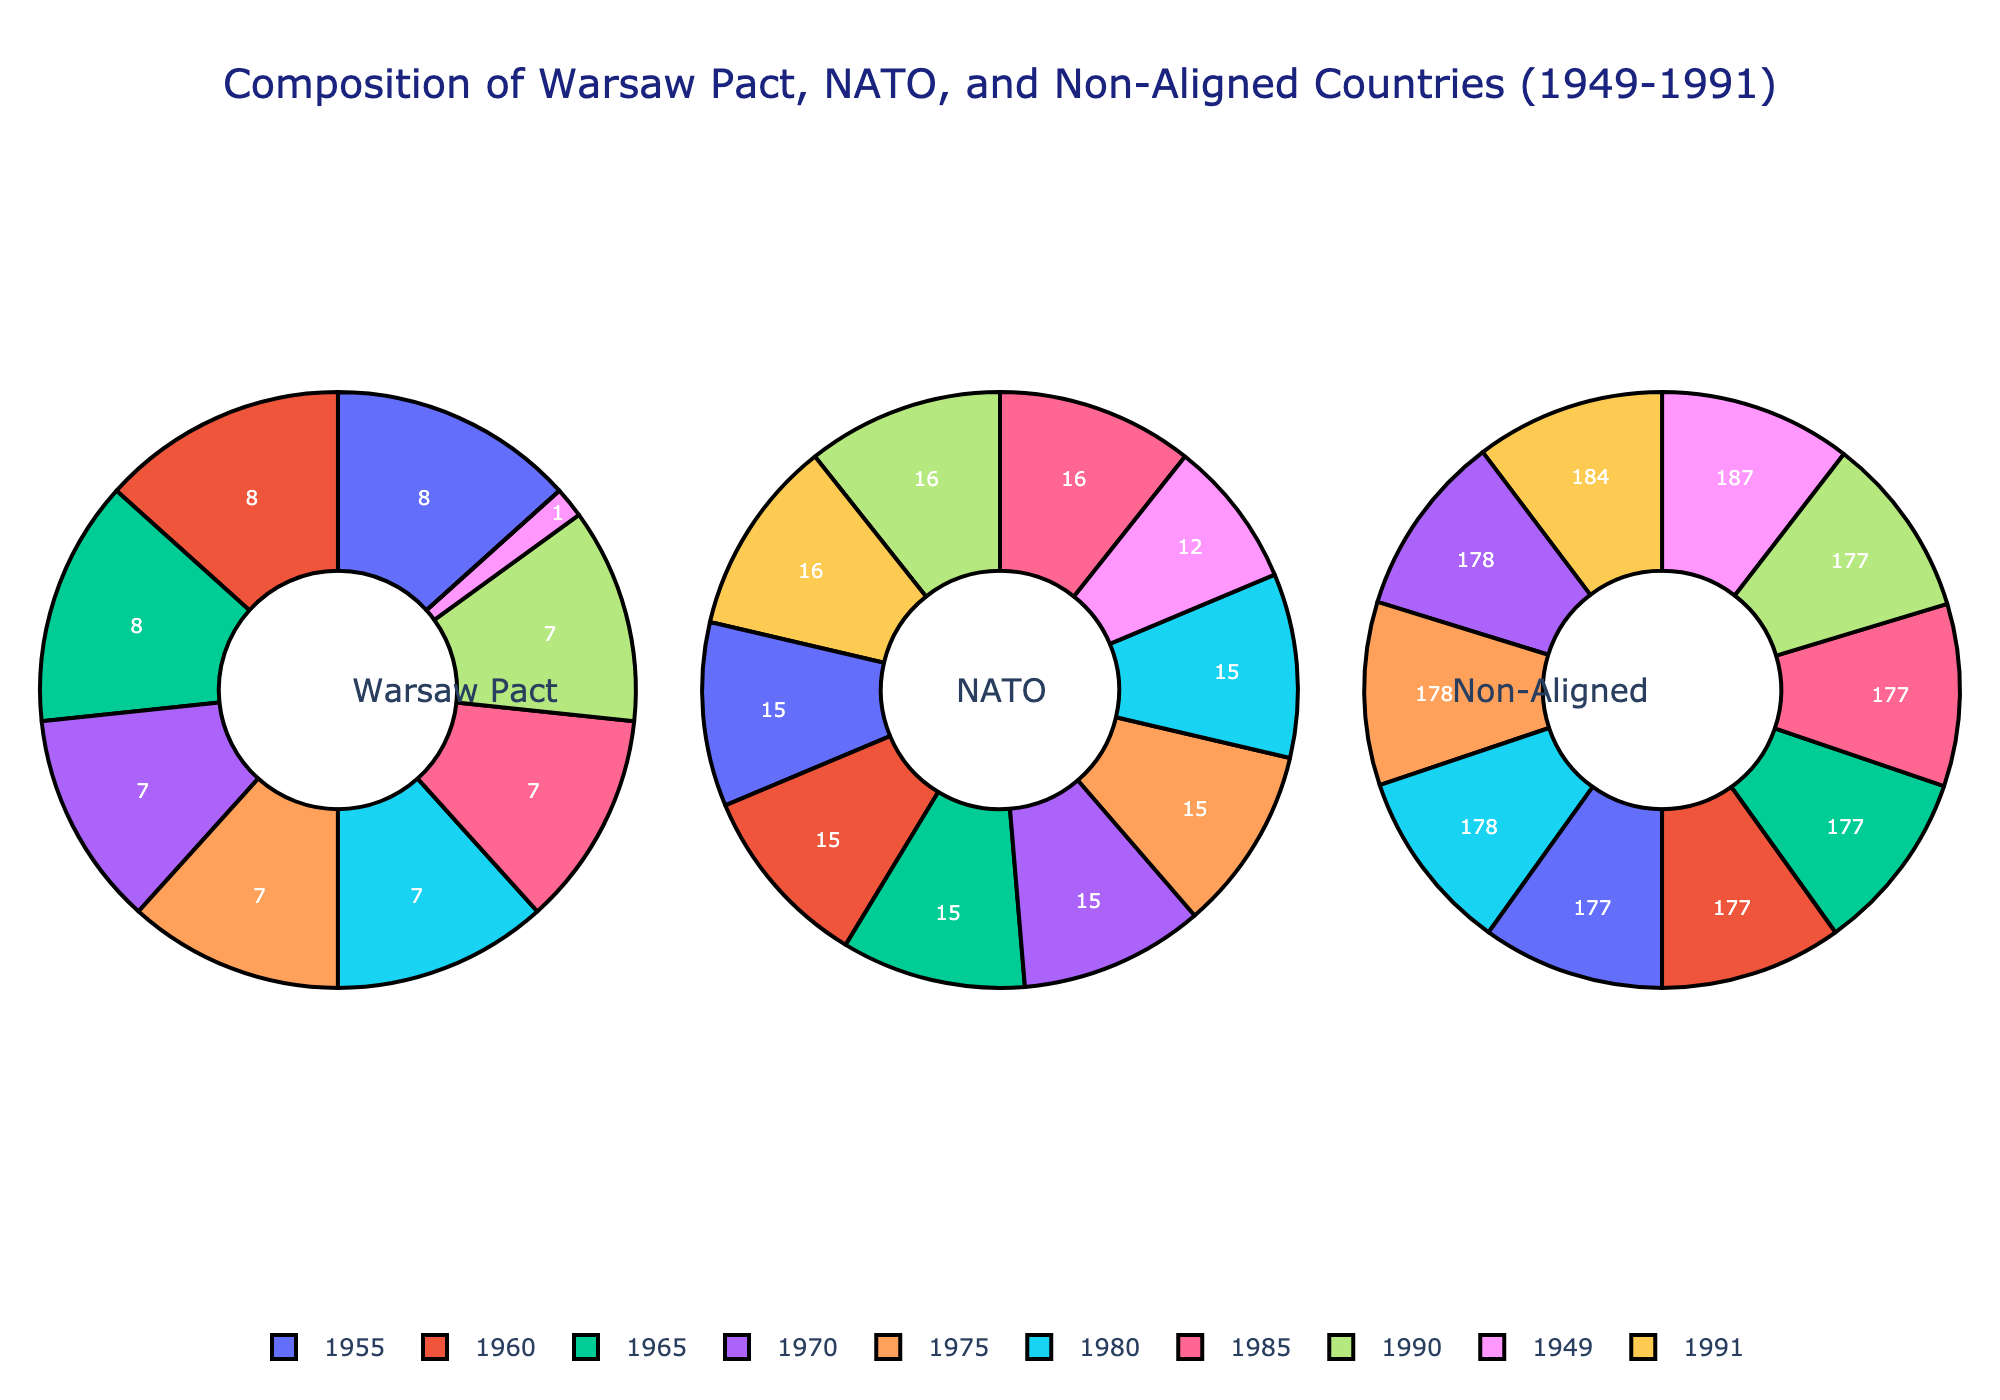What year had the highest number of Warsaw Pact members? Observe the pie chart section for Warsaw Pact members. The peak color section (larger slice) for Warsaw Pact members is in 1955 with 8 members.
Answer: 1955 How does the number of NATO members in 1949 compare with the number of Warsaw Pact members in 1955? NATO had 12 members in 1949 while Warsaw Pact had 8 members in 1955. This is evident by comparing the sizes of their respective pie chart sections for these years. 12 > 8.
Answer: NATO > Warsaw Pact What is the median number of NATO members throughout the years? To find the median, list the values for NATO members: 12, 15, 15, 15, 15, 15, 15, 16, 16, 16. The median value is the average of the 5th and 6th values in the ordered list: (15 + 15)/2 = 15.
Answer: 15 In what year did the number of Warsaw Pact members drop to zero? Look for the pie chart of the Warsaw Pact section where the slice disappears completely. This happens in 1991.
Answer: 1991 What can be visually inferred about the non-aligned countries throughout the years? The slices representing non-aligned countries change minimally, suggesting a steady and dominating number over the years. Notice the large, consistent section in the non-aligned category.
Answer: Steady count Compare the sum of Warsaw Pact and NATO members in 1985. In 1985, Warsaw Pact had 7 members and NATO had 16 members. Adding them gives 7 + 16 = 23.
Answer: 23 What year marks the first entry of countries into NATO after its initial members in 1949? By looking at the NATO section of the pie chart, we note that the count increases from 12 in 1949 to 15 in 1955, indicating new entries.
Answer: 1955 How does the change in Warsaw Pact members from 1970 to 1975 compare against the change in NATO members from 1985 to 1990? Warsaw Pact members see no change (7 to 7) between 1970 and 1975. NATO members remain static as well (16 to 16) between 1985 and 1990. Both show no change.
Answer: No change Which group retained the maximum membership number consistently from 1949 to 1991? In each pie chart, non-aligned countries have the largest slice, indicating the highest number perpetually.
Answer: Non-aligned Consider the year 1990. How do the slices for Warsaw Pact and non-aligned group visually compare? The Warsaw Pact slice is much smaller than the non-aligned group in 1990, just by observation. The non-aligned slice is significantly larger.
Answer: Non-Aligned larger than Warsaw Pact 